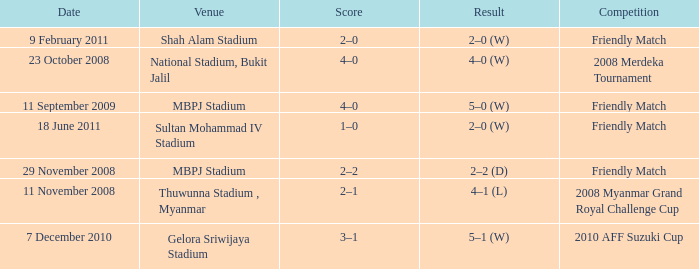What Competition in Shah Alam Stadium have a Result of 2–0 (w)? Friendly Match. 